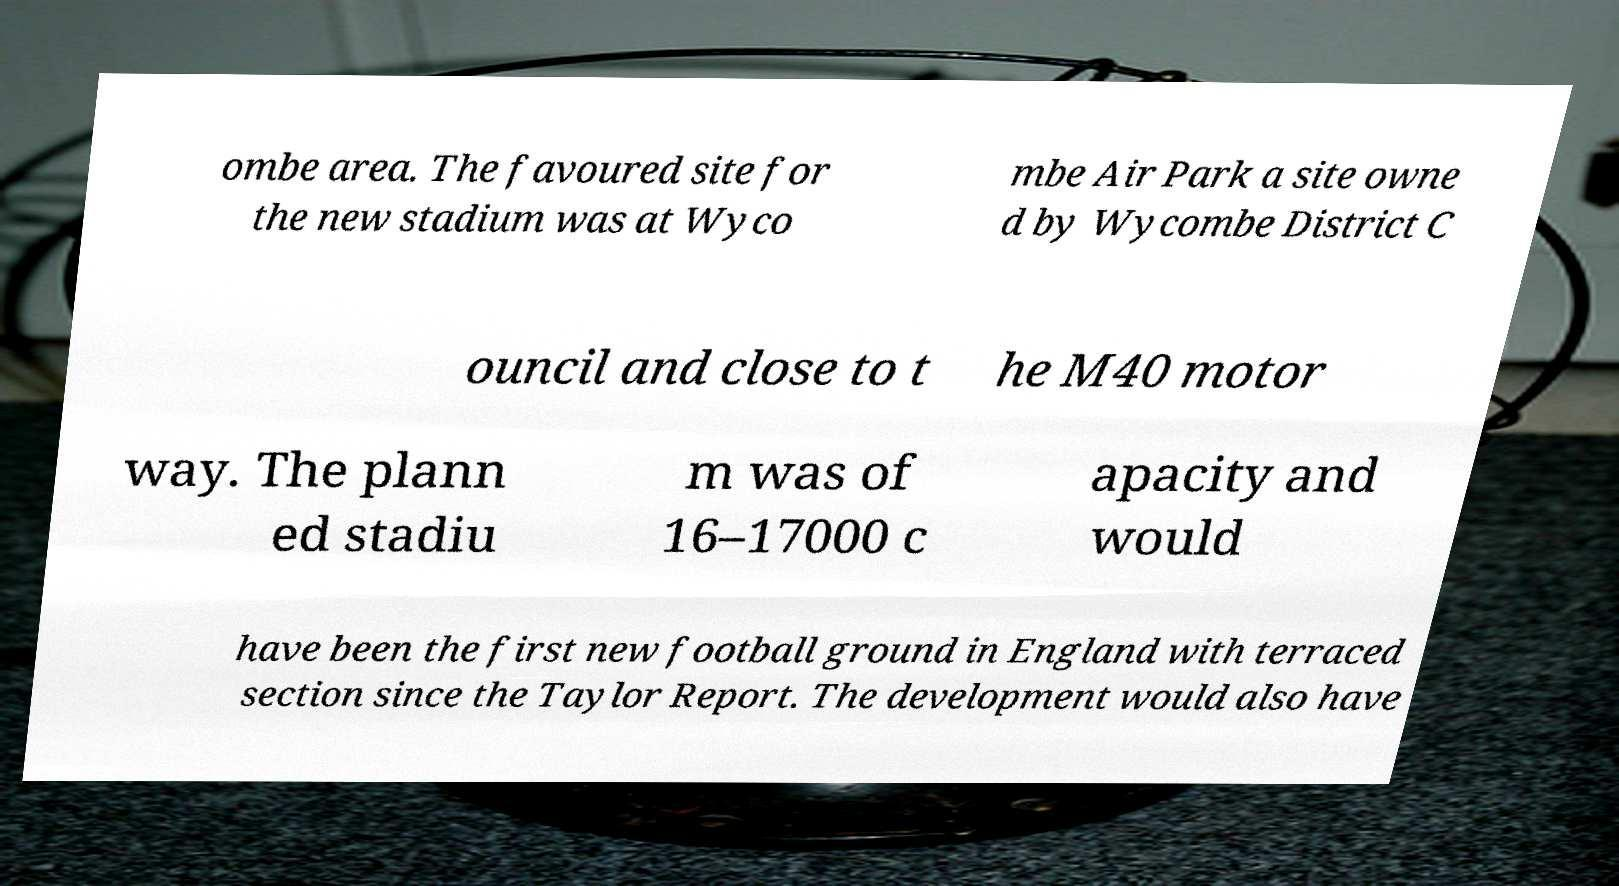I need the written content from this picture converted into text. Can you do that? ombe area. The favoured site for the new stadium was at Wyco mbe Air Park a site owne d by Wycombe District C ouncil and close to t he M40 motor way. The plann ed stadiu m was of 16–17000 c apacity and would have been the first new football ground in England with terraced section since the Taylor Report. The development would also have 